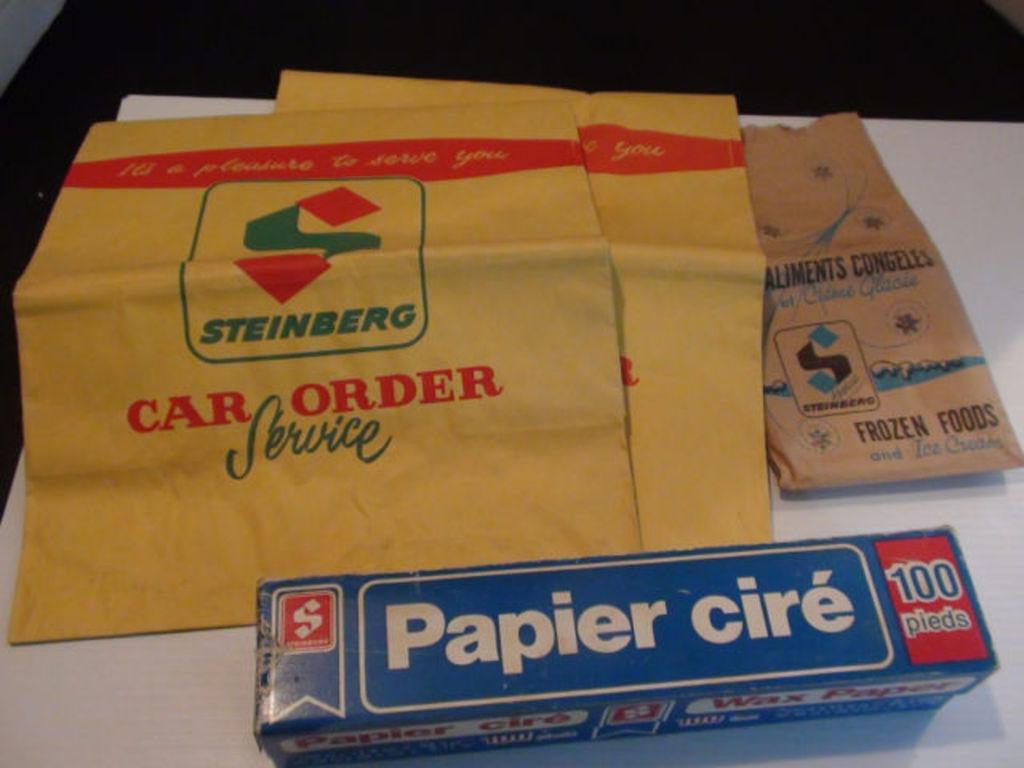What company is named on the yellow napkins?
Your answer should be compact. Steinberg. What is in the blue box?
Your answer should be compact. Papier cire . 